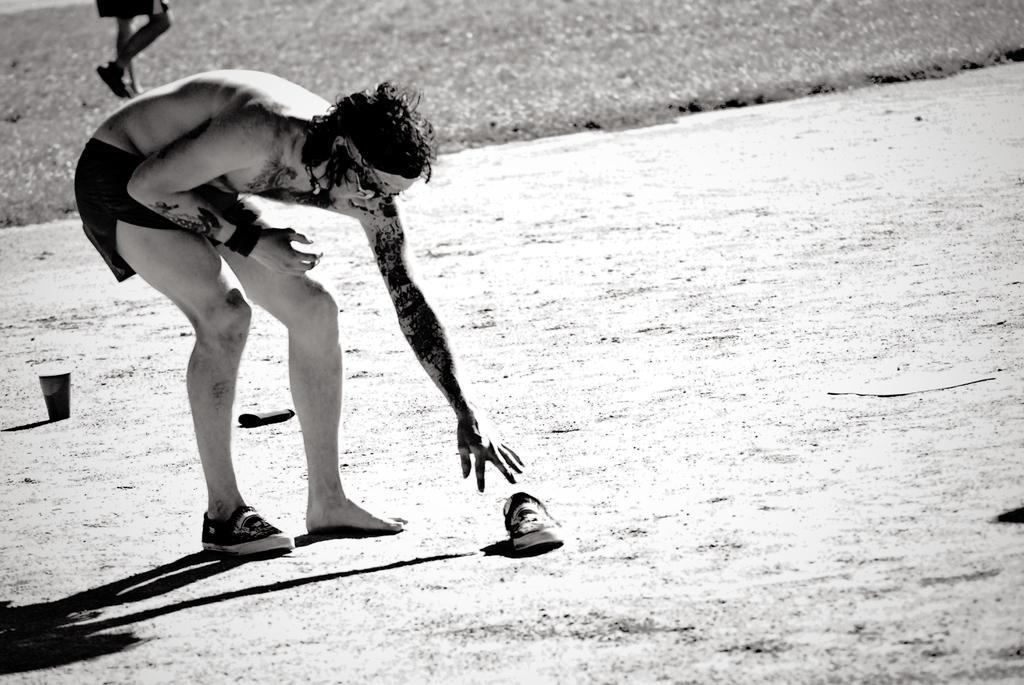Please provide a concise description of this image. This is a black and white image. In the image, on the left side there is a man bending. And in front of him there is a shoe. Behind him there is another person walking. And also there is a glass. 